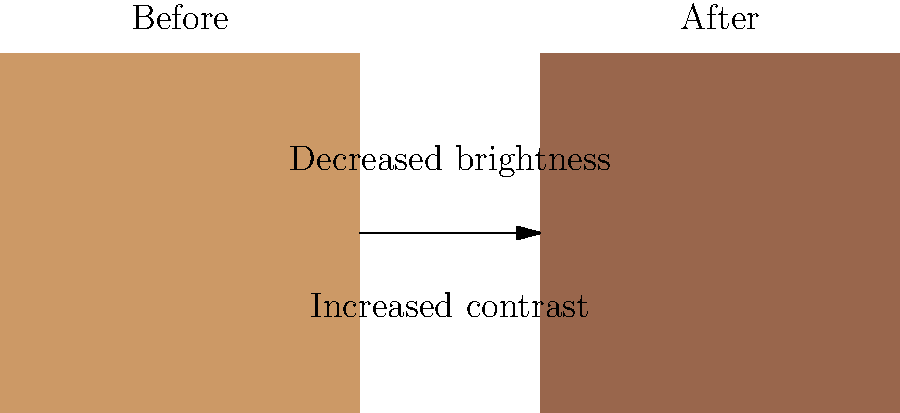In the color grading process for your latest independent film inspired by the "Highlander" franchise, you want to create a more dramatic and moody atmosphere. Based on the before and after examples shown, which specific color grading technique has been primarily applied to achieve this effect? To determine the color grading technique applied, let's analyze the changes from the "Before" to "After" image:

1. Overall darkness: The image has become darker, indicated by the shift from a lighter brown (rgb(0.8,0.6,0.4)) to a darker brown (rgb(0.6,0.4,0.3)).

2. Contrast: The darker areas appear to have become even darker, while the lighter areas remain relatively unchanged, suggesting an increase in contrast.

3. Color temperature: There's a slight shift towards cooler tones, but this is not the primary change.

4. Saturation: The colors appear slightly less saturated in the "After" image, but this is not the most significant change.

The most prominent change is the overall darkening of the image while maintaining some lighter areas, which is characteristic of the "crushing the blacks" technique. This technique involves darkening the shadow areas of an image more than the highlights, which increases contrast and creates a more dramatic, moody atmosphere.

This technique is often used in films to create a more cinematic look, particularly in genres like action, thriller, or fantasy - which aligns well with the "Highlander" franchise's style. It's a popular choice for independent filmmakers looking to achieve a professional, dramatic look on a budget.
Answer: Crushing the blacks 